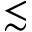<formula> <loc_0><loc_0><loc_500><loc_500>\lesssim</formula> 